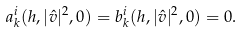<formula> <loc_0><loc_0><loc_500><loc_500>a _ { k } ^ { i } ( h , | \hat { v } | ^ { 2 } , 0 ) = b _ { k } ^ { i } ( h , | \hat { v } | ^ { 2 } , 0 ) = 0 .</formula> 